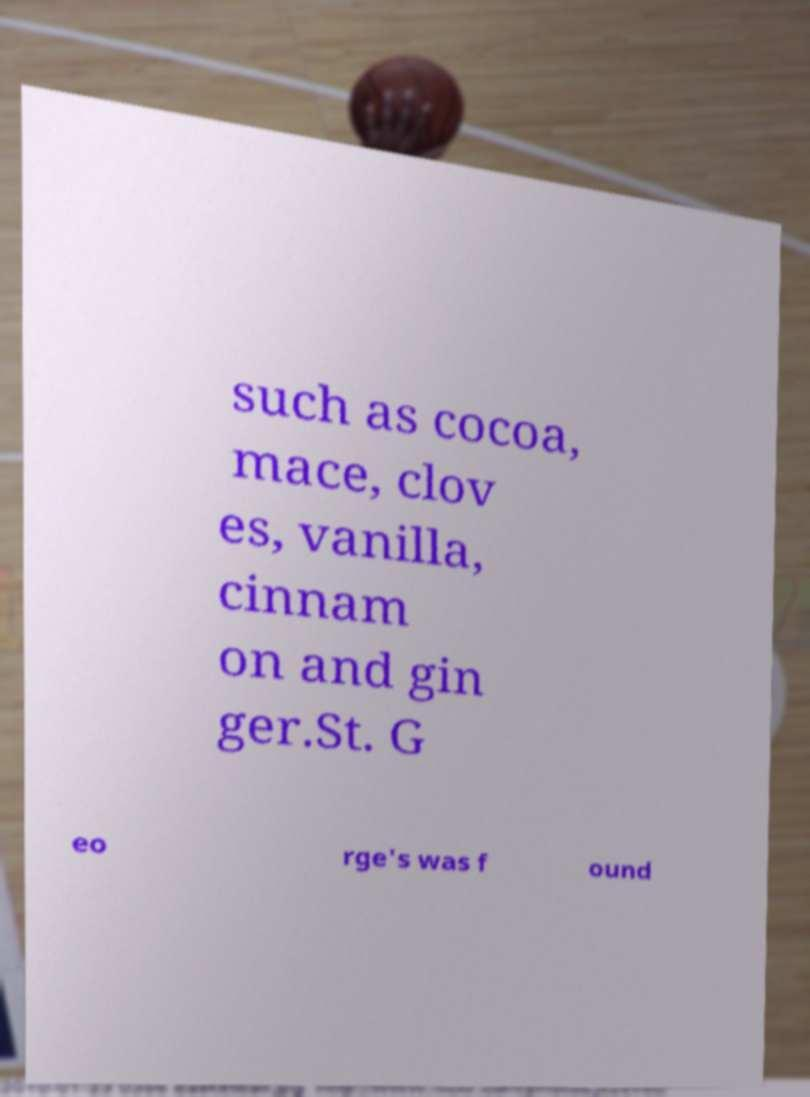There's text embedded in this image that I need extracted. Can you transcribe it verbatim? such as cocoa, mace, clov es, vanilla, cinnam on and gin ger.St. G eo rge's was f ound 